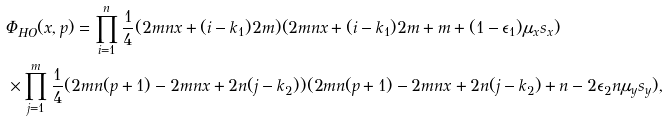<formula> <loc_0><loc_0><loc_500><loc_500>& \Phi _ { H O } ( x , p ) = \prod _ { i = 1 } ^ { n } \frac { 1 } { 4 } ( 2 m n x + ( i - k _ { 1 } ) 2 m ) ( 2 m n x + ( i - k _ { 1 } ) 2 m + m + ( 1 - \epsilon _ { 1 } ) \mu _ { x } s _ { x } ) \\ & \times \prod _ { j = 1 } ^ { m } \frac { 1 } { 4 } ( 2 m n ( p + 1 ) - 2 m n x + 2 n ( j - k _ { 2 } ) ) ( 2 m n ( p + 1 ) - 2 m n x + 2 n ( j - k _ { 2 } ) + n - 2 \epsilon _ { 2 } n \mu _ { y } s _ { y } ) ,</formula> 